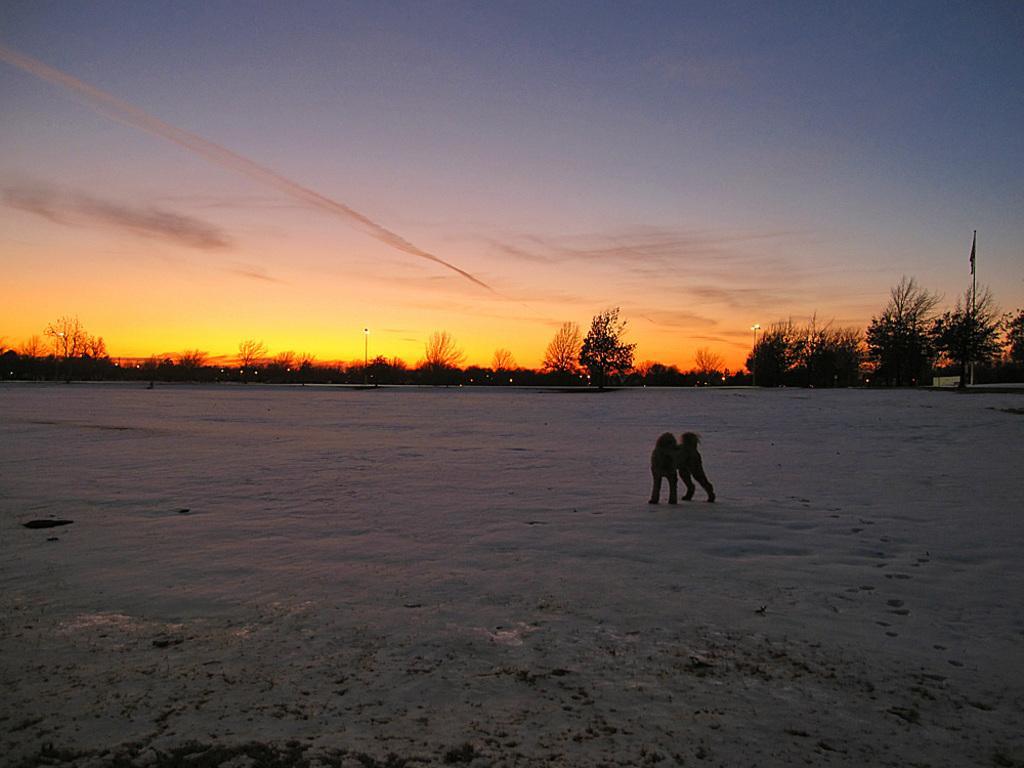Please provide a concise description of this image. In this picture I can see there is a animal standing here on the snow and there are trees and poles in the backdrop. 